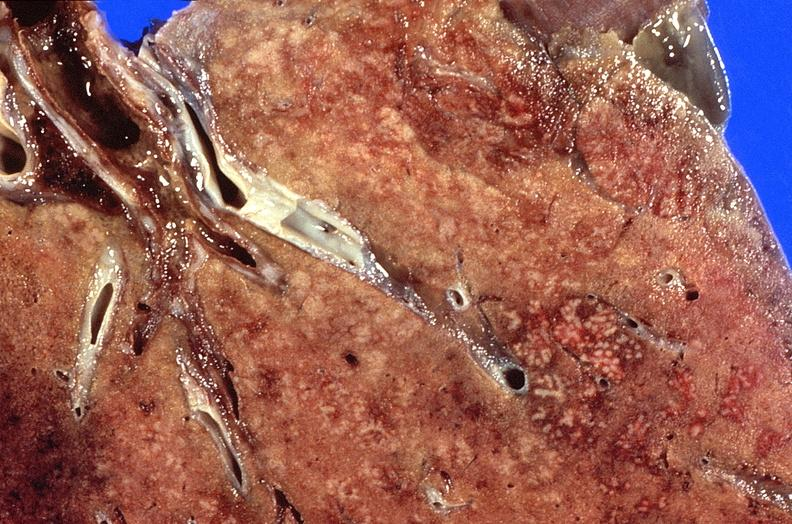s a bulge present?
Answer the question using a single word or phrase. No 